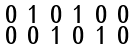Convert formula to latex. <formula><loc_0><loc_0><loc_500><loc_500>\begin{smallmatrix} 0 & 1 & 0 & 1 & 0 & 0 & \\ 0 & 0 & 1 & 0 & 1 & 0 & \\ \end{smallmatrix}</formula> 